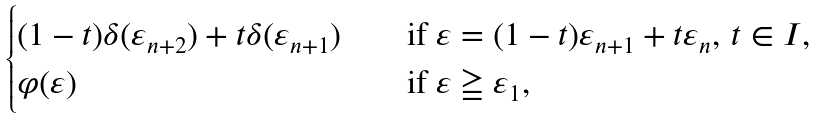<formula> <loc_0><loc_0><loc_500><loc_500>\begin{cases} ( 1 - t ) \delta ( \varepsilon _ { n + 2 } ) + t \delta ( \varepsilon _ { n + 1 } ) \quad & \text {if } \varepsilon = ( 1 - t ) \varepsilon _ { n + 1 } + t \varepsilon _ { n } , \, t \in I , \\ \varphi ( \varepsilon ) & \text {if } \varepsilon \geqq \varepsilon _ { 1 } , \end{cases}</formula> 